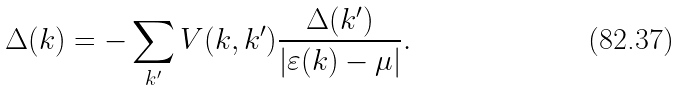Convert formula to latex. <formula><loc_0><loc_0><loc_500><loc_500>\Delta ( { k } ) = - \sum _ { k ^ { \prime } } V ( { k } , { k ^ { \prime } } ) \frac { \Delta ( { k ^ { \prime } } ) } { | \varepsilon ( { k } ) - \mu | } .</formula> 